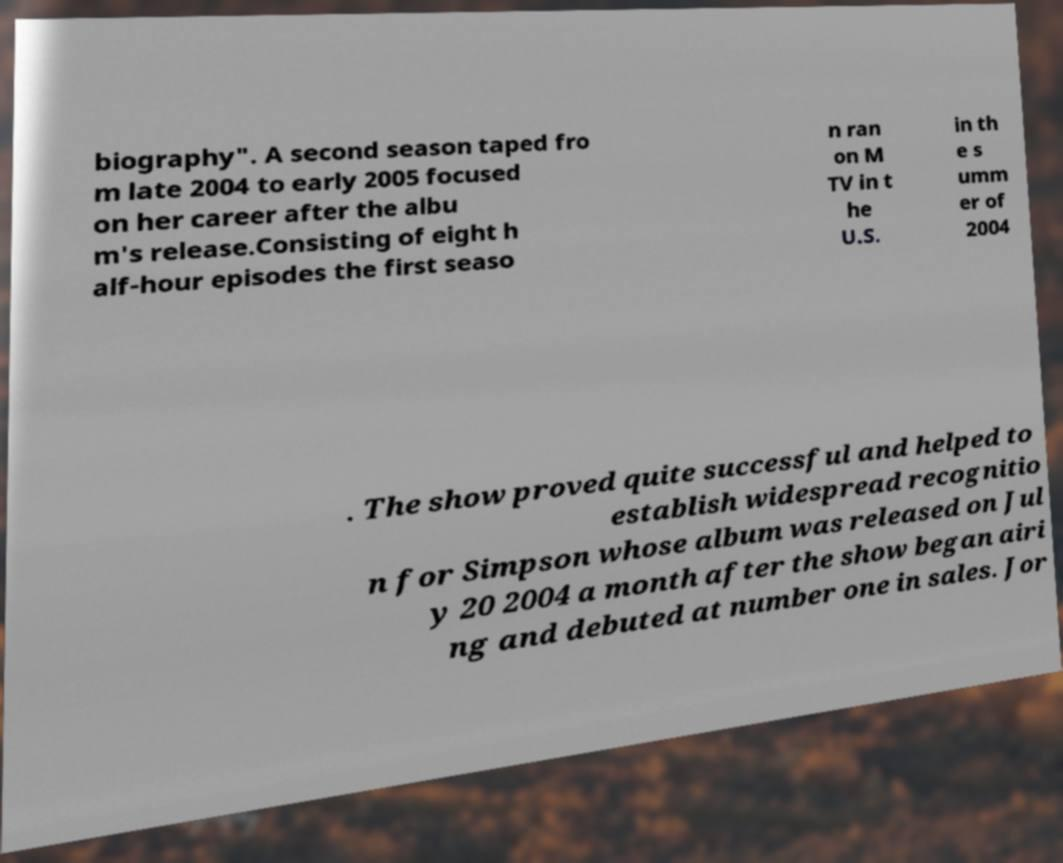Can you read and provide the text displayed in the image?This photo seems to have some interesting text. Can you extract and type it out for me? biography". A second season taped fro m late 2004 to early 2005 focused on her career after the albu m's release.Consisting of eight h alf-hour episodes the first seaso n ran on M TV in t he U.S. in th e s umm er of 2004 . The show proved quite successful and helped to establish widespread recognitio n for Simpson whose album was released on Jul y 20 2004 a month after the show began airi ng and debuted at number one in sales. Jor 